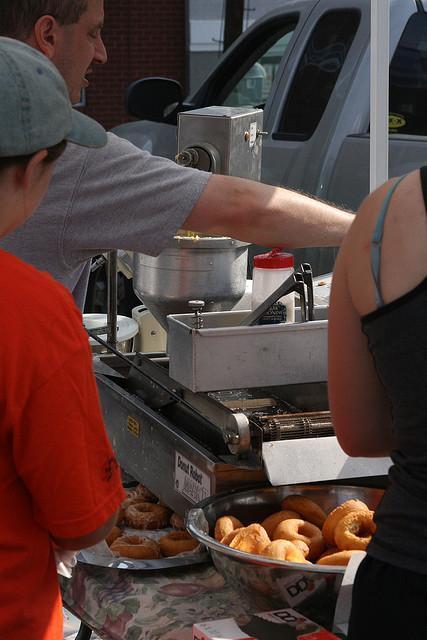How many people are visible?
Give a very brief answer. 3. How many people are in the picture?
Give a very brief answer. 3. 